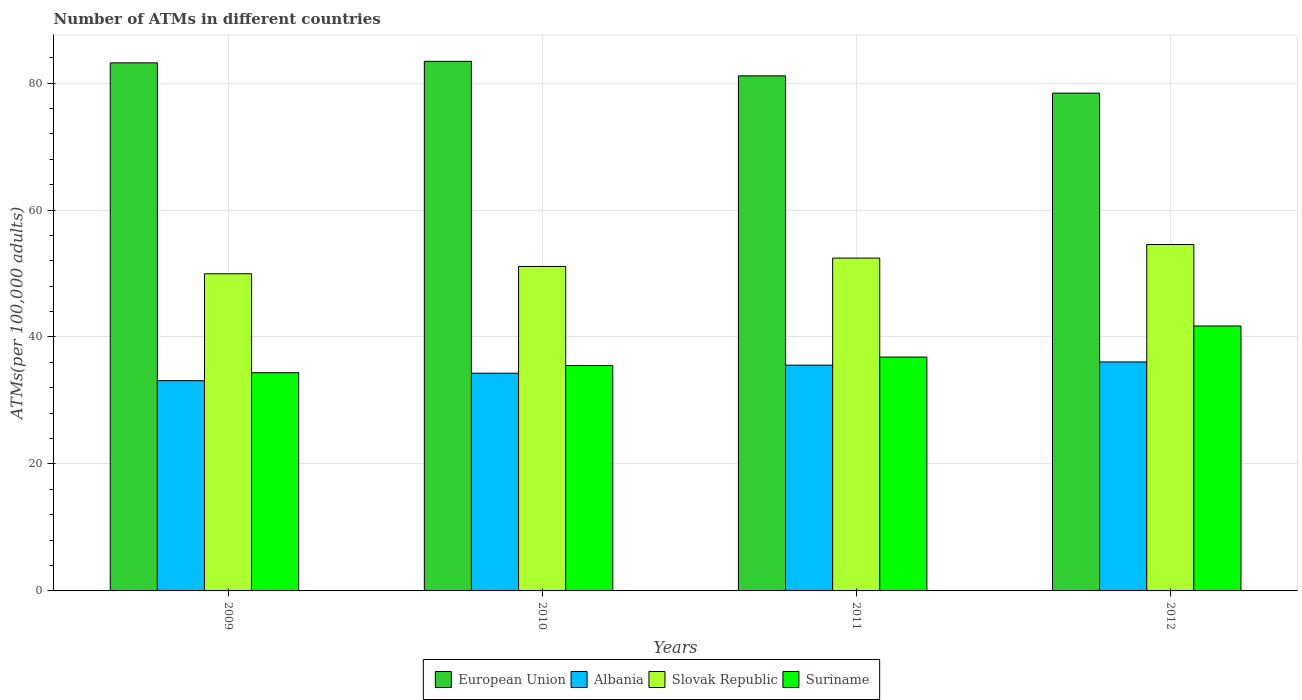How many different coloured bars are there?
Offer a very short reply. 4. How many groups of bars are there?
Your answer should be compact. 4. How many bars are there on the 2nd tick from the left?
Make the answer very short. 4. What is the label of the 3rd group of bars from the left?
Offer a very short reply. 2011. In how many cases, is the number of bars for a given year not equal to the number of legend labels?
Offer a very short reply. 0. What is the number of ATMs in Albania in 2010?
Make the answer very short. 34.3. Across all years, what is the maximum number of ATMs in European Union?
Keep it short and to the point. 83.42. Across all years, what is the minimum number of ATMs in Slovak Republic?
Make the answer very short. 49.96. In which year was the number of ATMs in Slovak Republic maximum?
Your response must be concise. 2012. What is the total number of ATMs in Slovak Republic in the graph?
Offer a terse response. 208.07. What is the difference between the number of ATMs in Slovak Republic in 2011 and that in 2012?
Your answer should be very brief. -2.14. What is the difference between the number of ATMs in European Union in 2011 and the number of ATMs in Albania in 2010?
Ensure brevity in your answer.  46.84. What is the average number of ATMs in Albania per year?
Give a very brief answer. 34.76. In the year 2010, what is the difference between the number of ATMs in European Union and number of ATMs in Suriname?
Make the answer very short. 47.92. What is the ratio of the number of ATMs in Slovak Republic in 2010 to that in 2011?
Offer a terse response. 0.97. Is the number of ATMs in Suriname in 2009 less than that in 2010?
Your answer should be compact. Yes. What is the difference between the highest and the second highest number of ATMs in Suriname?
Your response must be concise. 4.9. What is the difference between the highest and the lowest number of ATMs in Suriname?
Ensure brevity in your answer.  7.36. Is the sum of the number of ATMs in Slovak Republic in 2010 and 2012 greater than the maximum number of ATMs in European Union across all years?
Offer a terse response. Yes. What does the 2nd bar from the left in 2010 represents?
Offer a terse response. Albania. What does the 3rd bar from the right in 2009 represents?
Make the answer very short. Albania. Is it the case that in every year, the sum of the number of ATMs in Suriname and number of ATMs in Albania is greater than the number of ATMs in European Union?
Offer a terse response. No. How many bars are there?
Your answer should be compact. 16. Are all the bars in the graph horizontal?
Provide a short and direct response. No. How many years are there in the graph?
Give a very brief answer. 4. What is the difference between two consecutive major ticks on the Y-axis?
Your response must be concise. 20. Where does the legend appear in the graph?
Provide a short and direct response. Bottom center. How are the legend labels stacked?
Your response must be concise. Horizontal. What is the title of the graph?
Give a very brief answer. Number of ATMs in different countries. What is the label or title of the X-axis?
Your answer should be very brief. Years. What is the label or title of the Y-axis?
Provide a short and direct response. ATMs(per 100,0 adults). What is the ATMs(per 100,000 adults) in European Union in 2009?
Your answer should be very brief. 83.18. What is the ATMs(per 100,000 adults) in Albania in 2009?
Offer a terse response. 33.12. What is the ATMs(per 100,000 adults) of Slovak Republic in 2009?
Offer a very short reply. 49.96. What is the ATMs(per 100,000 adults) in Suriname in 2009?
Offer a very short reply. 34.37. What is the ATMs(per 100,000 adults) of European Union in 2010?
Keep it short and to the point. 83.42. What is the ATMs(per 100,000 adults) in Albania in 2010?
Offer a very short reply. 34.3. What is the ATMs(per 100,000 adults) in Slovak Republic in 2010?
Ensure brevity in your answer.  51.12. What is the ATMs(per 100,000 adults) in Suriname in 2010?
Offer a very short reply. 35.5. What is the ATMs(per 100,000 adults) of European Union in 2011?
Give a very brief answer. 81.14. What is the ATMs(per 100,000 adults) in Albania in 2011?
Keep it short and to the point. 35.56. What is the ATMs(per 100,000 adults) in Slovak Republic in 2011?
Provide a short and direct response. 52.43. What is the ATMs(per 100,000 adults) of Suriname in 2011?
Your response must be concise. 36.83. What is the ATMs(per 100,000 adults) of European Union in 2012?
Keep it short and to the point. 78.41. What is the ATMs(per 100,000 adults) in Albania in 2012?
Keep it short and to the point. 36.07. What is the ATMs(per 100,000 adults) in Slovak Republic in 2012?
Give a very brief answer. 54.57. What is the ATMs(per 100,000 adults) of Suriname in 2012?
Give a very brief answer. 41.73. Across all years, what is the maximum ATMs(per 100,000 adults) of European Union?
Keep it short and to the point. 83.42. Across all years, what is the maximum ATMs(per 100,000 adults) in Albania?
Your answer should be compact. 36.07. Across all years, what is the maximum ATMs(per 100,000 adults) in Slovak Republic?
Your response must be concise. 54.57. Across all years, what is the maximum ATMs(per 100,000 adults) of Suriname?
Provide a succinct answer. 41.73. Across all years, what is the minimum ATMs(per 100,000 adults) in European Union?
Keep it short and to the point. 78.41. Across all years, what is the minimum ATMs(per 100,000 adults) of Albania?
Your response must be concise. 33.12. Across all years, what is the minimum ATMs(per 100,000 adults) in Slovak Republic?
Your answer should be very brief. 49.96. Across all years, what is the minimum ATMs(per 100,000 adults) in Suriname?
Your answer should be compact. 34.37. What is the total ATMs(per 100,000 adults) in European Union in the graph?
Make the answer very short. 326.15. What is the total ATMs(per 100,000 adults) of Albania in the graph?
Offer a terse response. 139.04. What is the total ATMs(per 100,000 adults) of Slovak Republic in the graph?
Offer a very short reply. 208.07. What is the total ATMs(per 100,000 adults) of Suriname in the graph?
Make the answer very short. 148.44. What is the difference between the ATMs(per 100,000 adults) of European Union in 2009 and that in 2010?
Give a very brief answer. -0.24. What is the difference between the ATMs(per 100,000 adults) of Albania in 2009 and that in 2010?
Your response must be concise. -1.18. What is the difference between the ATMs(per 100,000 adults) of Slovak Republic in 2009 and that in 2010?
Make the answer very short. -1.16. What is the difference between the ATMs(per 100,000 adults) of Suriname in 2009 and that in 2010?
Your answer should be compact. -1.13. What is the difference between the ATMs(per 100,000 adults) in European Union in 2009 and that in 2011?
Provide a short and direct response. 2.05. What is the difference between the ATMs(per 100,000 adults) of Albania in 2009 and that in 2011?
Provide a short and direct response. -2.45. What is the difference between the ATMs(per 100,000 adults) in Slovak Republic in 2009 and that in 2011?
Provide a succinct answer. -2.47. What is the difference between the ATMs(per 100,000 adults) in Suriname in 2009 and that in 2011?
Give a very brief answer. -2.46. What is the difference between the ATMs(per 100,000 adults) in European Union in 2009 and that in 2012?
Your answer should be very brief. 4.77. What is the difference between the ATMs(per 100,000 adults) in Albania in 2009 and that in 2012?
Your answer should be very brief. -2.95. What is the difference between the ATMs(per 100,000 adults) of Slovak Republic in 2009 and that in 2012?
Keep it short and to the point. -4.61. What is the difference between the ATMs(per 100,000 adults) in Suriname in 2009 and that in 2012?
Your answer should be compact. -7.36. What is the difference between the ATMs(per 100,000 adults) of European Union in 2010 and that in 2011?
Ensure brevity in your answer.  2.28. What is the difference between the ATMs(per 100,000 adults) in Albania in 2010 and that in 2011?
Offer a terse response. -1.27. What is the difference between the ATMs(per 100,000 adults) in Slovak Republic in 2010 and that in 2011?
Give a very brief answer. -1.31. What is the difference between the ATMs(per 100,000 adults) of Suriname in 2010 and that in 2011?
Give a very brief answer. -1.33. What is the difference between the ATMs(per 100,000 adults) in European Union in 2010 and that in 2012?
Provide a short and direct response. 5. What is the difference between the ATMs(per 100,000 adults) of Albania in 2010 and that in 2012?
Your response must be concise. -1.77. What is the difference between the ATMs(per 100,000 adults) of Slovak Republic in 2010 and that in 2012?
Give a very brief answer. -3.45. What is the difference between the ATMs(per 100,000 adults) of Suriname in 2010 and that in 2012?
Your answer should be compact. -6.23. What is the difference between the ATMs(per 100,000 adults) in European Union in 2011 and that in 2012?
Give a very brief answer. 2.72. What is the difference between the ATMs(per 100,000 adults) of Albania in 2011 and that in 2012?
Offer a very short reply. -0.5. What is the difference between the ATMs(per 100,000 adults) in Slovak Republic in 2011 and that in 2012?
Make the answer very short. -2.14. What is the difference between the ATMs(per 100,000 adults) in Suriname in 2011 and that in 2012?
Your response must be concise. -4.9. What is the difference between the ATMs(per 100,000 adults) in European Union in 2009 and the ATMs(per 100,000 adults) in Albania in 2010?
Offer a terse response. 48.89. What is the difference between the ATMs(per 100,000 adults) of European Union in 2009 and the ATMs(per 100,000 adults) of Slovak Republic in 2010?
Offer a very short reply. 32.07. What is the difference between the ATMs(per 100,000 adults) of European Union in 2009 and the ATMs(per 100,000 adults) of Suriname in 2010?
Keep it short and to the point. 47.68. What is the difference between the ATMs(per 100,000 adults) in Albania in 2009 and the ATMs(per 100,000 adults) in Slovak Republic in 2010?
Provide a succinct answer. -18. What is the difference between the ATMs(per 100,000 adults) in Albania in 2009 and the ATMs(per 100,000 adults) in Suriname in 2010?
Your answer should be compact. -2.39. What is the difference between the ATMs(per 100,000 adults) of Slovak Republic in 2009 and the ATMs(per 100,000 adults) of Suriname in 2010?
Provide a short and direct response. 14.46. What is the difference between the ATMs(per 100,000 adults) in European Union in 2009 and the ATMs(per 100,000 adults) in Albania in 2011?
Offer a very short reply. 47.62. What is the difference between the ATMs(per 100,000 adults) in European Union in 2009 and the ATMs(per 100,000 adults) in Slovak Republic in 2011?
Make the answer very short. 30.75. What is the difference between the ATMs(per 100,000 adults) of European Union in 2009 and the ATMs(per 100,000 adults) of Suriname in 2011?
Ensure brevity in your answer.  46.35. What is the difference between the ATMs(per 100,000 adults) in Albania in 2009 and the ATMs(per 100,000 adults) in Slovak Republic in 2011?
Provide a succinct answer. -19.31. What is the difference between the ATMs(per 100,000 adults) in Albania in 2009 and the ATMs(per 100,000 adults) in Suriname in 2011?
Offer a terse response. -3.72. What is the difference between the ATMs(per 100,000 adults) in Slovak Republic in 2009 and the ATMs(per 100,000 adults) in Suriname in 2011?
Make the answer very short. 13.12. What is the difference between the ATMs(per 100,000 adults) of European Union in 2009 and the ATMs(per 100,000 adults) of Albania in 2012?
Keep it short and to the point. 47.12. What is the difference between the ATMs(per 100,000 adults) in European Union in 2009 and the ATMs(per 100,000 adults) in Slovak Republic in 2012?
Your answer should be very brief. 28.62. What is the difference between the ATMs(per 100,000 adults) in European Union in 2009 and the ATMs(per 100,000 adults) in Suriname in 2012?
Your answer should be very brief. 41.45. What is the difference between the ATMs(per 100,000 adults) of Albania in 2009 and the ATMs(per 100,000 adults) of Slovak Republic in 2012?
Offer a terse response. -21.45. What is the difference between the ATMs(per 100,000 adults) of Albania in 2009 and the ATMs(per 100,000 adults) of Suriname in 2012?
Offer a very short reply. -8.62. What is the difference between the ATMs(per 100,000 adults) in Slovak Republic in 2009 and the ATMs(per 100,000 adults) in Suriname in 2012?
Offer a terse response. 8.22. What is the difference between the ATMs(per 100,000 adults) of European Union in 2010 and the ATMs(per 100,000 adults) of Albania in 2011?
Ensure brevity in your answer.  47.86. What is the difference between the ATMs(per 100,000 adults) of European Union in 2010 and the ATMs(per 100,000 adults) of Slovak Republic in 2011?
Provide a short and direct response. 30.99. What is the difference between the ATMs(per 100,000 adults) of European Union in 2010 and the ATMs(per 100,000 adults) of Suriname in 2011?
Your answer should be compact. 46.58. What is the difference between the ATMs(per 100,000 adults) in Albania in 2010 and the ATMs(per 100,000 adults) in Slovak Republic in 2011?
Offer a very short reply. -18.13. What is the difference between the ATMs(per 100,000 adults) in Albania in 2010 and the ATMs(per 100,000 adults) in Suriname in 2011?
Keep it short and to the point. -2.54. What is the difference between the ATMs(per 100,000 adults) in Slovak Republic in 2010 and the ATMs(per 100,000 adults) in Suriname in 2011?
Make the answer very short. 14.28. What is the difference between the ATMs(per 100,000 adults) of European Union in 2010 and the ATMs(per 100,000 adults) of Albania in 2012?
Provide a short and direct response. 47.35. What is the difference between the ATMs(per 100,000 adults) of European Union in 2010 and the ATMs(per 100,000 adults) of Slovak Republic in 2012?
Provide a short and direct response. 28.85. What is the difference between the ATMs(per 100,000 adults) of European Union in 2010 and the ATMs(per 100,000 adults) of Suriname in 2012?
Your response must be concise. 41.68. What is the difference between the ATMs(per 100,000 adults) in Albania in 2010 and the ATMs(per 100,000 adults) in Slovak Republic in 2012?
Offer a terse response. -20.27. What is the difference between the ATMs(per 100,000 adults) in Albania in 2010 and the ATMs(per 100,000 adults) in Suriname in 2012?
Make the answer very short. -7.44. What is the difference between the ATMs(per 100,000 adults) of Slovak Republic in 2010 and the ATMs(per 100,000 adults) of Suriname in 2012?
Provide a succinct answer. 9.38. What is the difference between the ATMs(per 100,000 adults) of European Union in 2011 and the ATMs(per 100,000 adults) of Albania in 2012?
Your answer should be compact. 45.07. What is the difference between the ATMs(per 100,000 adults) of European Union in 2011 and the ATMs(per 100,000 adults) of Slovak Republic in 2012?
Offer a terse response. 26.57. What is the difference between the ATMs(per 100,000 adults) of European Union in 2011 and the ATMs(per 100,000 adults) of Suriname in 2012?
Your answer should be very brief. 39.4. What is the difference between the ATMs(per 100,000 adults) in Albania in 2011 and the ATMs(per 100,000 adults) in Slovak Republic in 2012?
Offer a terse response. -19. What is the difference between the ATMs(per 100,000 adults) in Albania in 2011 and the ATMs(per 100,000 adults) in Suriname in 2012?
Provide a short and direct response. -6.17. What is the difference between the ATMs(per 100,000 adults) in Slovak Republic in 2011 and the ATMs(per 100,000 adults) in Suriname in 2012?
Your response must be concise. 10.7. What is the average ATMs(per 100,000 adults) of European Union per year?
Offer a terse response. 81.54. What is the average ATMs(per 100,000 adults) of Albania per year?
Offer a very short reply. 34.76. What is the average ATMs(per 100,000 adults) in Slovak Republic per year?
Provide a succinct answer. 52.02. What is the average ATMs(per 100,000 adults) of Suriname per year?
Ensure brevity in your answer.  37.11. In the year 2009, what is the difference between the ATMs(per 100,000 adults) in European Union and ATMs(per 100,000 adults) in Albania?
Offer a very short reply. 50.07. In the year 2009, what is the difference between the ATMs(per 100,000 adults) in European Union and ATMs(per 100,000 adults) in Slovak Republic?
Your response must be concise. 33.23. In the year 2009, what is the difference between the ATMs(per 100,000 adults) of European Union and ATMs(per 100,000 adults) of Suriname?
Your answer should be compact. 48.81. In the year 2009, what is the difference between the ATMs(per 100,000 adults) of Albania and ATMs(per 100,000 adults) of Slovak Republic?
Your answer should be very brief. -16.84. In the year 2009, what is the difference between the ATMs(per 100,000 adults) of Albania and ATMs(per 100,000 adults) of Suriname?
Offer a terse response. -1.26. In the year 2009, what is the difference between the ATMs(per 100,000 adults) of Slovak Republic and ATMs(per 100,000 adults) of Suriname?
Offer a terse response. 15.59. In the year 2010, what is the difference between the ATMs(per 100,000 adults) of European Union and ATMs(per 100,000 adults) of Albania?
Provide a short and direct response. 49.12. In the year 2010, what is the difference between the ATMs(per 100,000 adults) in European Union and ATMs(per 100,000 adults) in Slovak Republic?
Provide a short and direct response. 32.3. In the year 2010, what is the difference between the ATMs(per 100,000 adults) of European Union and ATMs(per 100,000 adults) of Suriname?
Provide a short and direct response. 47.92. In the year 2010, what is the difference between the ATMs(per 100,000 adults) in Albania and ATMs(per 100,000 adults) in Slovak Republic?
Keep it short and to the point. -16.82. In the year 2010, what is the difference between the ATMs(per 100,000 adults) in Albania and ATMs(per 100,000 adults) in Suriname?
Your answer should be compact. -1.21. In the year 2010, what is the difference between the ATMs(per 100,000 adults) of Slovak Republic and ATMs(per 100,000 adults) of Suriname?
Your response must be concise. 15.61. In the year 2011, what is the difference between the ATMs(per 100,000 adults) of European Union and ATMs(per 100,000 adults) of Albania?
Your answer should be compact. 45.57. In the year 2011, what is the difference between the ATMs(per 100,000 adults) in European Union and ATMs(per 100,000 adults) in Slovak Republic?
Offer a terse response. 28.71. In the year 2011, what is the difference between the ATMs(per 100,000 adults) of European Union and ATMs(per 100,000 adults) of Suriname?
Offer a terse response. 44.3. In the year 2011, what is the difference between the ATMs(per 100,000 adults) in Albania and ATMs(per 100,000 adults) in Slovak Republic?
Your answer should be compact. -16.87. In the year 2011, what is the difference between the ATMs(per 100,000 adults) in Albania and ATMs(per 100,000 adults) in Suriname?
Give a very brief answer. -1.27. In the year 2011, what is the difference between the ATMs(per 100,000 adults) of Slovak Republic and ATMs(per 100,000 adults) of Suriname?
Your answer should be very brief. 15.59. In the year 2012, what is the difference between the ATMs(per 100,000 adults) of European Union and ATMs(per 100,000 adults) of Albania?
Your answer should be compact. 42.35. In the year 2012, what is the difference between the ATMs(per 100,000 adults) of European Union and ATMs(per 100,000 adults) of Slovak Republic?
Provide a short and direct response. 23.85. In the year 2012, what is the difference between the ATMs(per 100,000 adults) of European Union and ATMs(per 100,000 adults) of Suriname?
Your answer should be very brief. 36.68. In the year 2012, what is the difference between the ATMs(per 100,000 adults) of Albania and ATMs(per 100,000 adults) of Slovak Republic?
Provide a succinct answer. -18.5. In the year 2012, what is the difference between the ATMs(per 100,000 adults) in Albania and ATMs(per 100,000 adults) in Suriname?
Ensure brevity in your answer.  -5.67. In the year 2012, what is the difference between the ATMs(per 100,000 adults) in Slovak Republic and ATMs(per 100,000 adults) in Suriname?
Your answer should be very brief. 12.83. What is the ratio of the ATMs(per 100,000 adults) in Albania in 2009 to that in 2010?
Give a very brief answer. 0.97. What is the ratio of the ATMs(per 100,000 adults) in Slovak Republic in 2009 to that in 2010?
Your response must be concise. 0.98. What is the ratio of the ATMs(per 100,000 adults) of Suriname in 2009 to that in 2010?
Provide a short and direct response. 0.97. What is the ratio of the ATMs(per 100,000 adults) in European Union in 2009 to that in 2011?
Offer a very short reply. 1.03. What is the ratio of the ATMs(per 100,000 adults) of Albania in 2009 to that in 2011?
Provide a short and direct response. 0.93. What is the ratio of the ATMs(per 100,000 adults) in Slovak Republic in 2009 to that in 2011?
Provide a succinct answer. 0.95. What is the ratio of the ATMs(per 100,000 adults) of Suriname in 2009 to that in 2011?
Offer a very short reply. 0.93. What is the ratio of the ATMs(per 100,000 adults) in European Union in 2009 to that in 2012?
Offer a very short reply. 1.06. What is the ratio of the ATMs(per 100,000 adults) of Albania in 2009 to that in 2012?
Provide a succinct answer. 0.92. What is the ratio of the ATMs(per 100,000 adults) in Slovak Republic in 2009 to that in 2012?
Offer a very short reply. 0.92. What is the ratio of the ATMs(per 100,000 adults) of Suriname in 2009 to that in 2012?
Your answer should be compact. 0.82. What is the ratio of the ATMs(per 100,000 adults) of European Union in 2010 to that in 2011?
Your answer should be compact. 1.03. What is the ratio of the ATMs(per 100,000 adults) in Albania in 2010 to that in 2011?
Make the answer very short. 0.96. What is the ratio of the ATMs(per 100,000 adults) of Slovak Republic in 2010 to that in 2011?
Your answer should be very brief. 0.97. What is the ratio of the ATMs(per 100,000 adults) in Suriname in 2010 to that in 2011?
Offer a terse response. 0.96. What is the ratio of the ATMs(per 100,000 adults) of European Union in 2010 to that in 2012?
Provide a succinct answer. 1.06. What is the ratio of the ATMs(per 100,000 adults) of Albania in 2010 to that in 2012?
Your answer should be compact. 0.95. What is the ratio of the ATMs(per 100,000 adults) of Slovak Republic in 2010 to that in 2012?
Give a very brief answer. 0.94. What is the ratio of the ATMs(per 100,000 adults) of Suriname in 2010 to that in 2012?
Ensure brevity in your answer.  0.85. What is the ratio of the ATMs(per 100,000 adults) of European Union in 2011 to that in 2012?
Offer a terse response. 1.03. What is the ratio of the ATMs(per 100,000 adults) of Albania in 2011 to that in 2012?
Give a very brief answer. 0.99. What is the ratio of the ATMs(per 100,000 adults) of Slovak Republic in 2011 to that in 2012?
Offer a very short reply. 0.96. What is the ratio of the ATMs(per 100,000 adults) in Suriname in 2011 to that in 2012?
Provide a short and direct response. 0.88. What is the difference between the highest and the second highest ATMs(per 100,000 adults) of European Union?
Provide a short and direct response. 0.24. What is the difference between the highest and the second highest ATMs(per 100,000 adults) in Albania?
Your answer should be very brief. 0.5. What is the difference between the highest and the second highest ATMs(per 100,000 adults) in Slovak Republic?
Your answer should be compact. 2.14. What is the difference between the highest and the second highest ATMs(per 100,000 adults) in Suriname?
Give a very brief answer. 4.9. What is the difference between the highest and the lowest ATMs(per 100,000 adults) in European Union?
Ensure brevity in your answer.  5. What is the difference between the highest and the lowest ATMs(per 100,000 adults) of Albania?
Your response must be concise. 2.95. What is the difference between the highest and the lowest ATMs(per 100,000 adults) in Slovak Republic?
Make the answer very short. 4.61. What is the difference between the highest and the lowest ATMs(per 100,000 adults) of Suriname?
Your answer should be very brief. 7.36. 